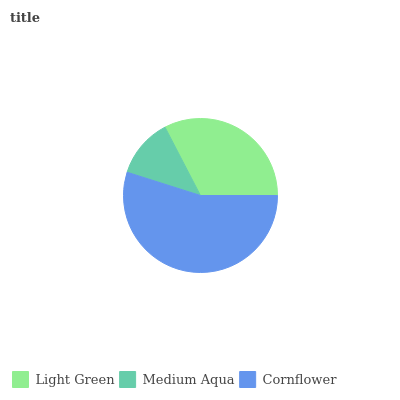Is Medium Aqua the minimum?
Answer yes or no. Yes. Is Cornflower the maximum?
Answer yes or no. Yes. Is Cornflower the minimum?
Answer yes or no. No. Is Medium Aqua the maximum?
Answer yes or no. No. Is Cornflower greater than Medium Aqua?
Answer yes or no. Yes. Is Medium Aqua less than Cornflower?
Answer yes or no. Yes. Is Medium Aqua greater than Cornflower?
Answer yes or no. No. Is Cornflower less than Medium Aqua?
Answer yes or no. No. Is Light Green the high median?
Answer yes or no. Yes. Is Light Green the low median?
Answer yes or no. Yes. Is Cornflower the high median?
Answer yes or no. No. Is Medium Aqua the low median?
Answer yes or no. No. 